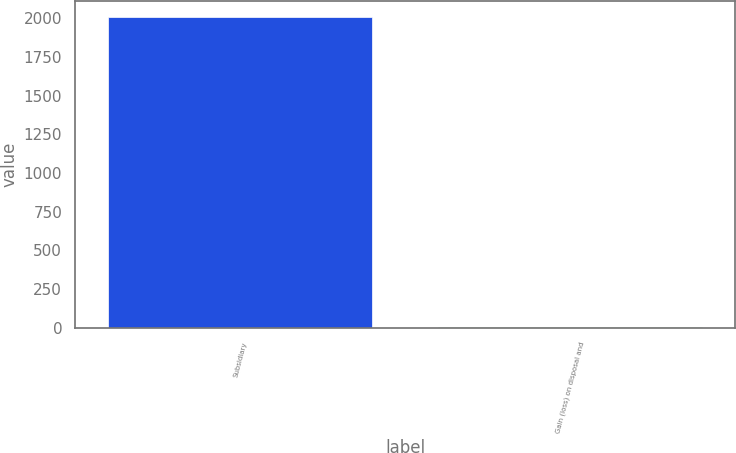Convert chart to OTSL. <chart><loc_0><loc_0><loc_500><loc_500><bar_chart><fcel>Subsidiary<fcel>Gain (loss) on disposal and<nl><fcel>2008<fcel>6<nl></chart> 